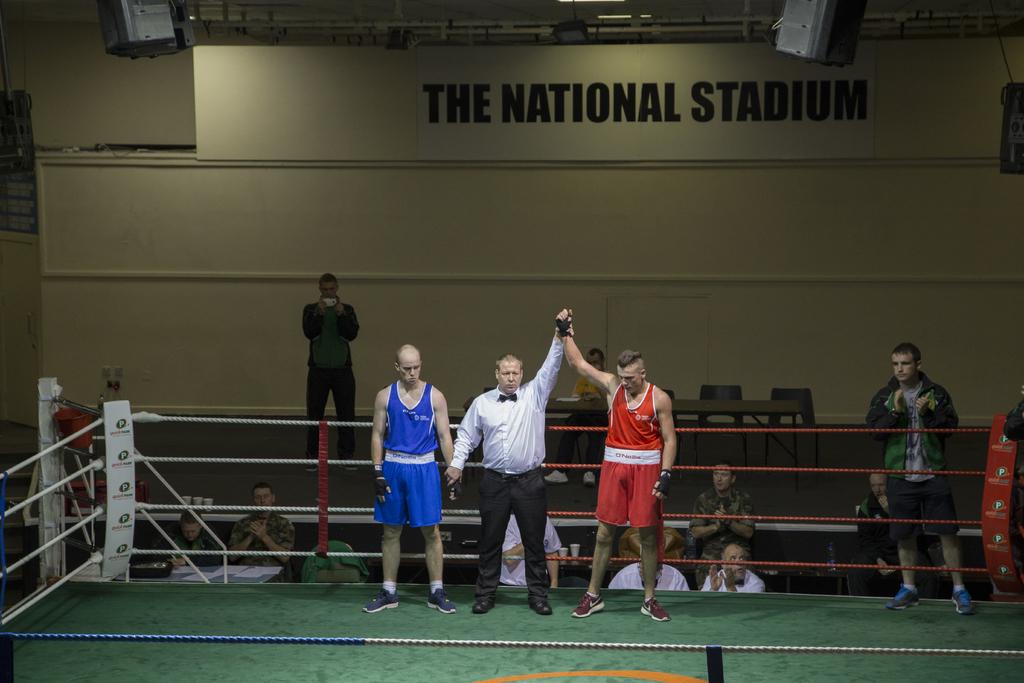Where is this?
Offer a terse response. The national stadium. What is written on the wall of the building?
Offer a terse response. The national stadium. 